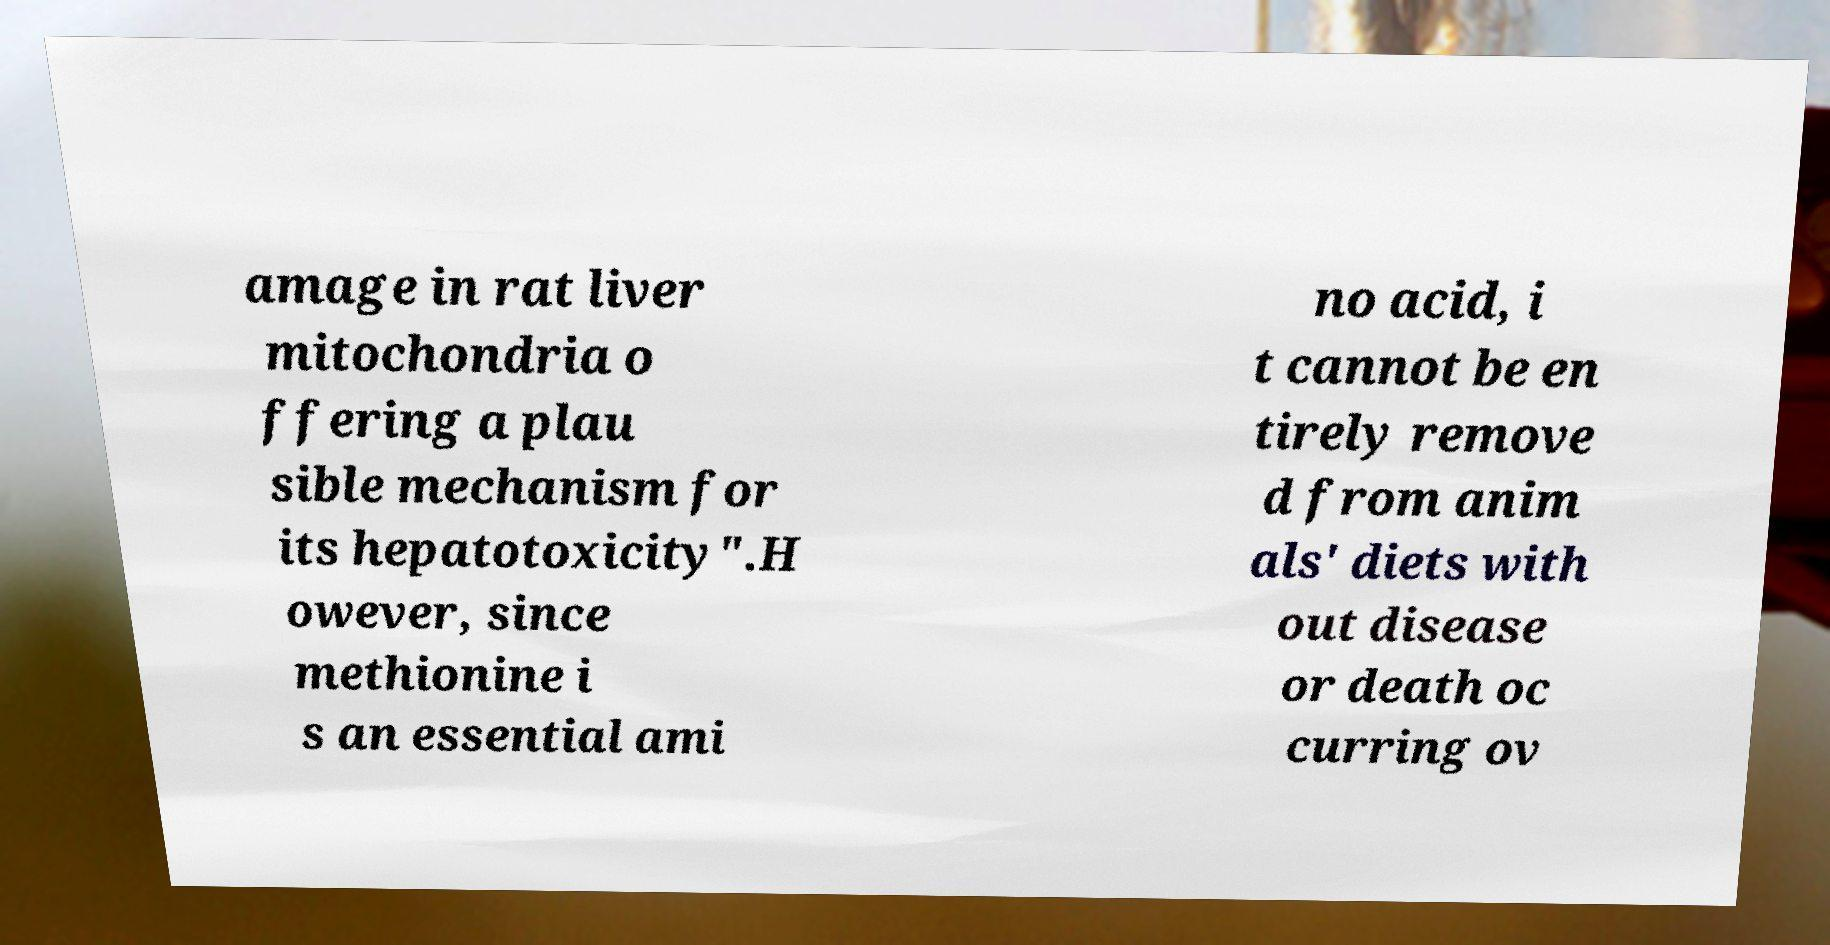Please read and relay the text visible in this image. What does it say? amage in rat liver mitochondria o ffering a plau sible mechanism for its hepatotoxicity".H owever, since methionine i s an essential ami no acid, i t cannot be en tirely remove d from anim als' diets with out disease or death oc curring ov 